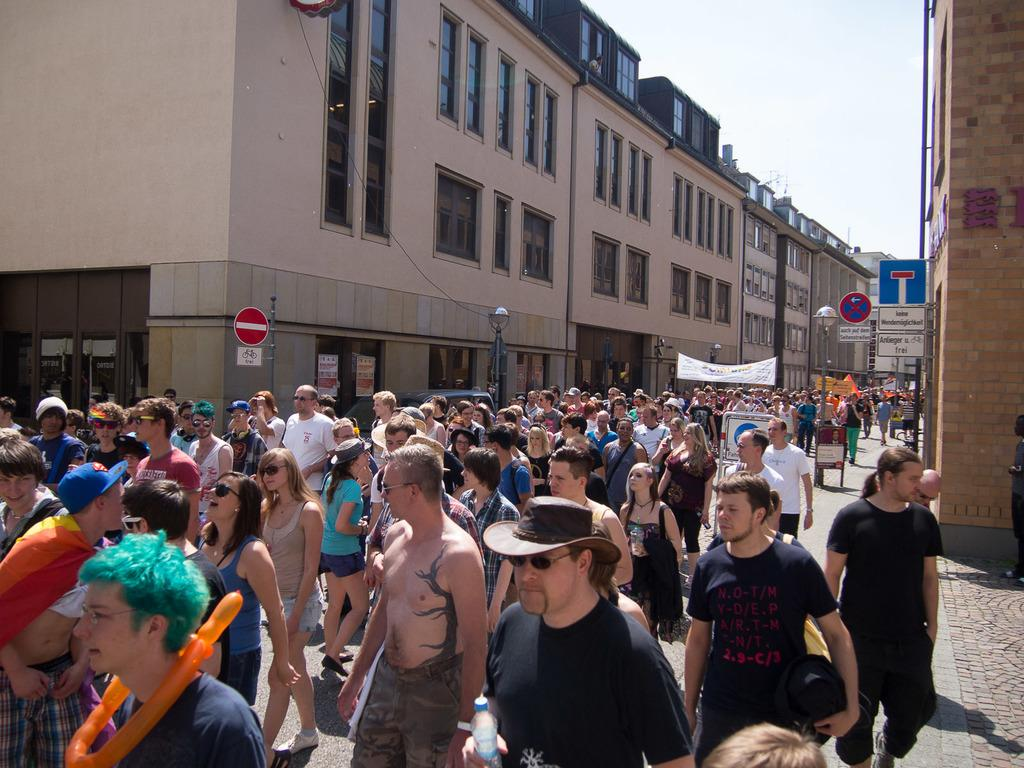What is happening in the image? There is a crowd of people in the image, and they are walking in the street. What can be seen in the background of the image? There are buildings in the background of the image. What is the condition of the sky in the image? The sky is clear in the image. Can you tell me how many nuts are being carried by the people in the image? There is no mention of nuts in the image, so it is impossible to determine how many nuts the people might be carrying. 